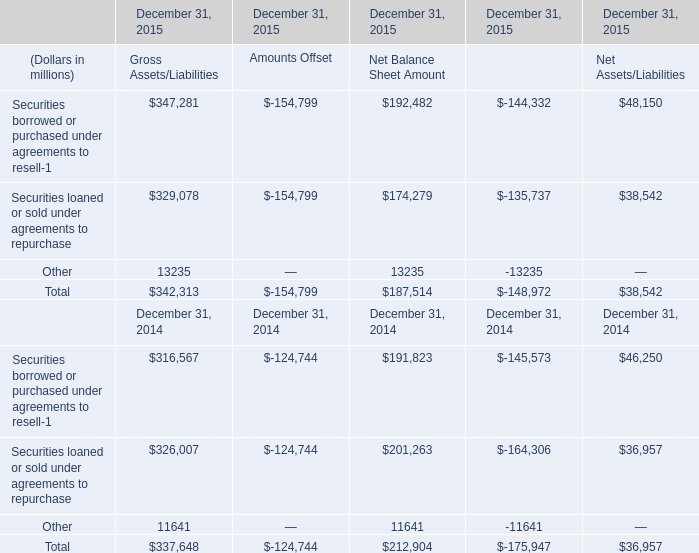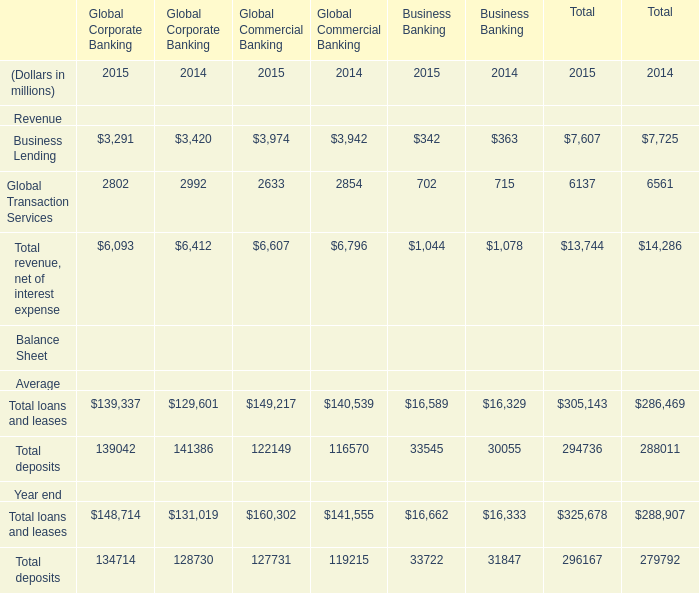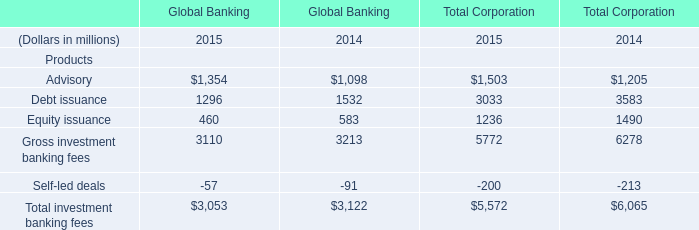In the year with largest amount of Debt issuance in table 2, what's the sum of Advisory in table 2? (in millions) 
Computations: (1098 + 1205)
Answer: 2303.0. 